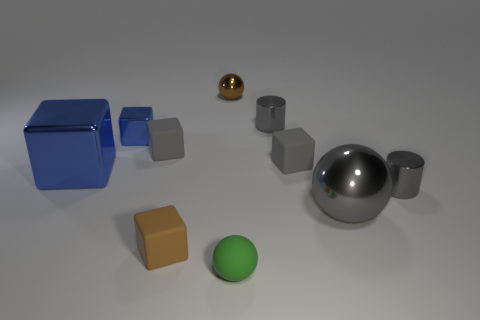What is the color of the sphere that is the same material as the brown block?
Give a very brief answer. Green. Are there more tiny purple matte cubes than small matte cubes?
Your answer should be compact. No. How big is the sphere that is both behind the green rubber sphere and in front of the small metal sphere?
Provide a short and direct response. Large. There is a small block that is the same color as the big block; what material is it?
Your response must be concise. Metal. Are there the same number of small green matte objects that are behind the tiny metallic ball and big purple matte cylinders?
Give a very brief answer. Yes. Do the rubber sphere and the gray shiny sphere have the same size?
Make the answer very short. No. What color is the small metal thing that is both behind the small metal block and in front of the tiny brown metallic object?
Your response must be concise. Gray. The brown thing behind the gray thing on the left side of the small green thing is made of what material?
Your response must be concise. Metal. There is a brown rubber object that is the same shape as the small blue metallic object; what is its size?
Ensure brevity in your answer.  Small. Is the color of the tiny rubber block on the right side of the small green object the same as the big shiny sphere?
Ensure brevity in your answer.  Yes. 